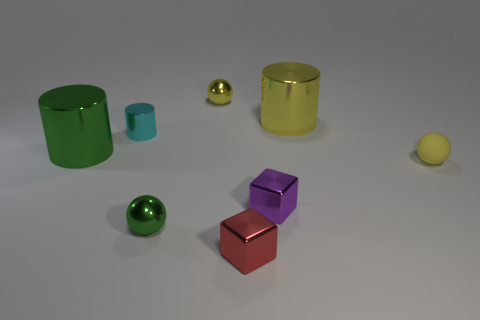Do the cyan cylinder and the green cylinder that is in front of the small cylinder have the same size?
Offer a very short reply. No. There is a tiny yellow thing that is in front of the green thing that is behind the tiny yellow rubber sphere; what is its material?
Provide a succinct answer. Rubber. How big is the yellow object left of the cylinder that is right of the yellow thing left of the tiny purple metal cube?
Give a very brief answer. Small. There is a small yellow matte object; is it the same shape as the tiny red object that is to the right of the small cyan shiny cylinder?
Your answer should be very brief. No. What is the material of the green sphere?
Your answer should be compact. Metal. How many metal things are either small cubes or small red blocks?
Offer a very short reply. 2. Is the number of big shiny cylinders that are right of the red thing less than the number of small red cubes to the right of the small yellow rubber thing?
Your answer should be compact. No. There is a large shiny object that is behind the thing that is to the left of the cyan shiny thing; is there a ball that is on the right side of it?
Ensure brevity in your answer.  Yes. What is the material of the other tiny sphere that is the same color as the rubber ball?
Your response must be concise. Metal. Do the large metallic thing to the right of the small red shiny object and the purple thing that is in front of the yellow rubber object have the same shape?
Keep it short and to the point. No. 